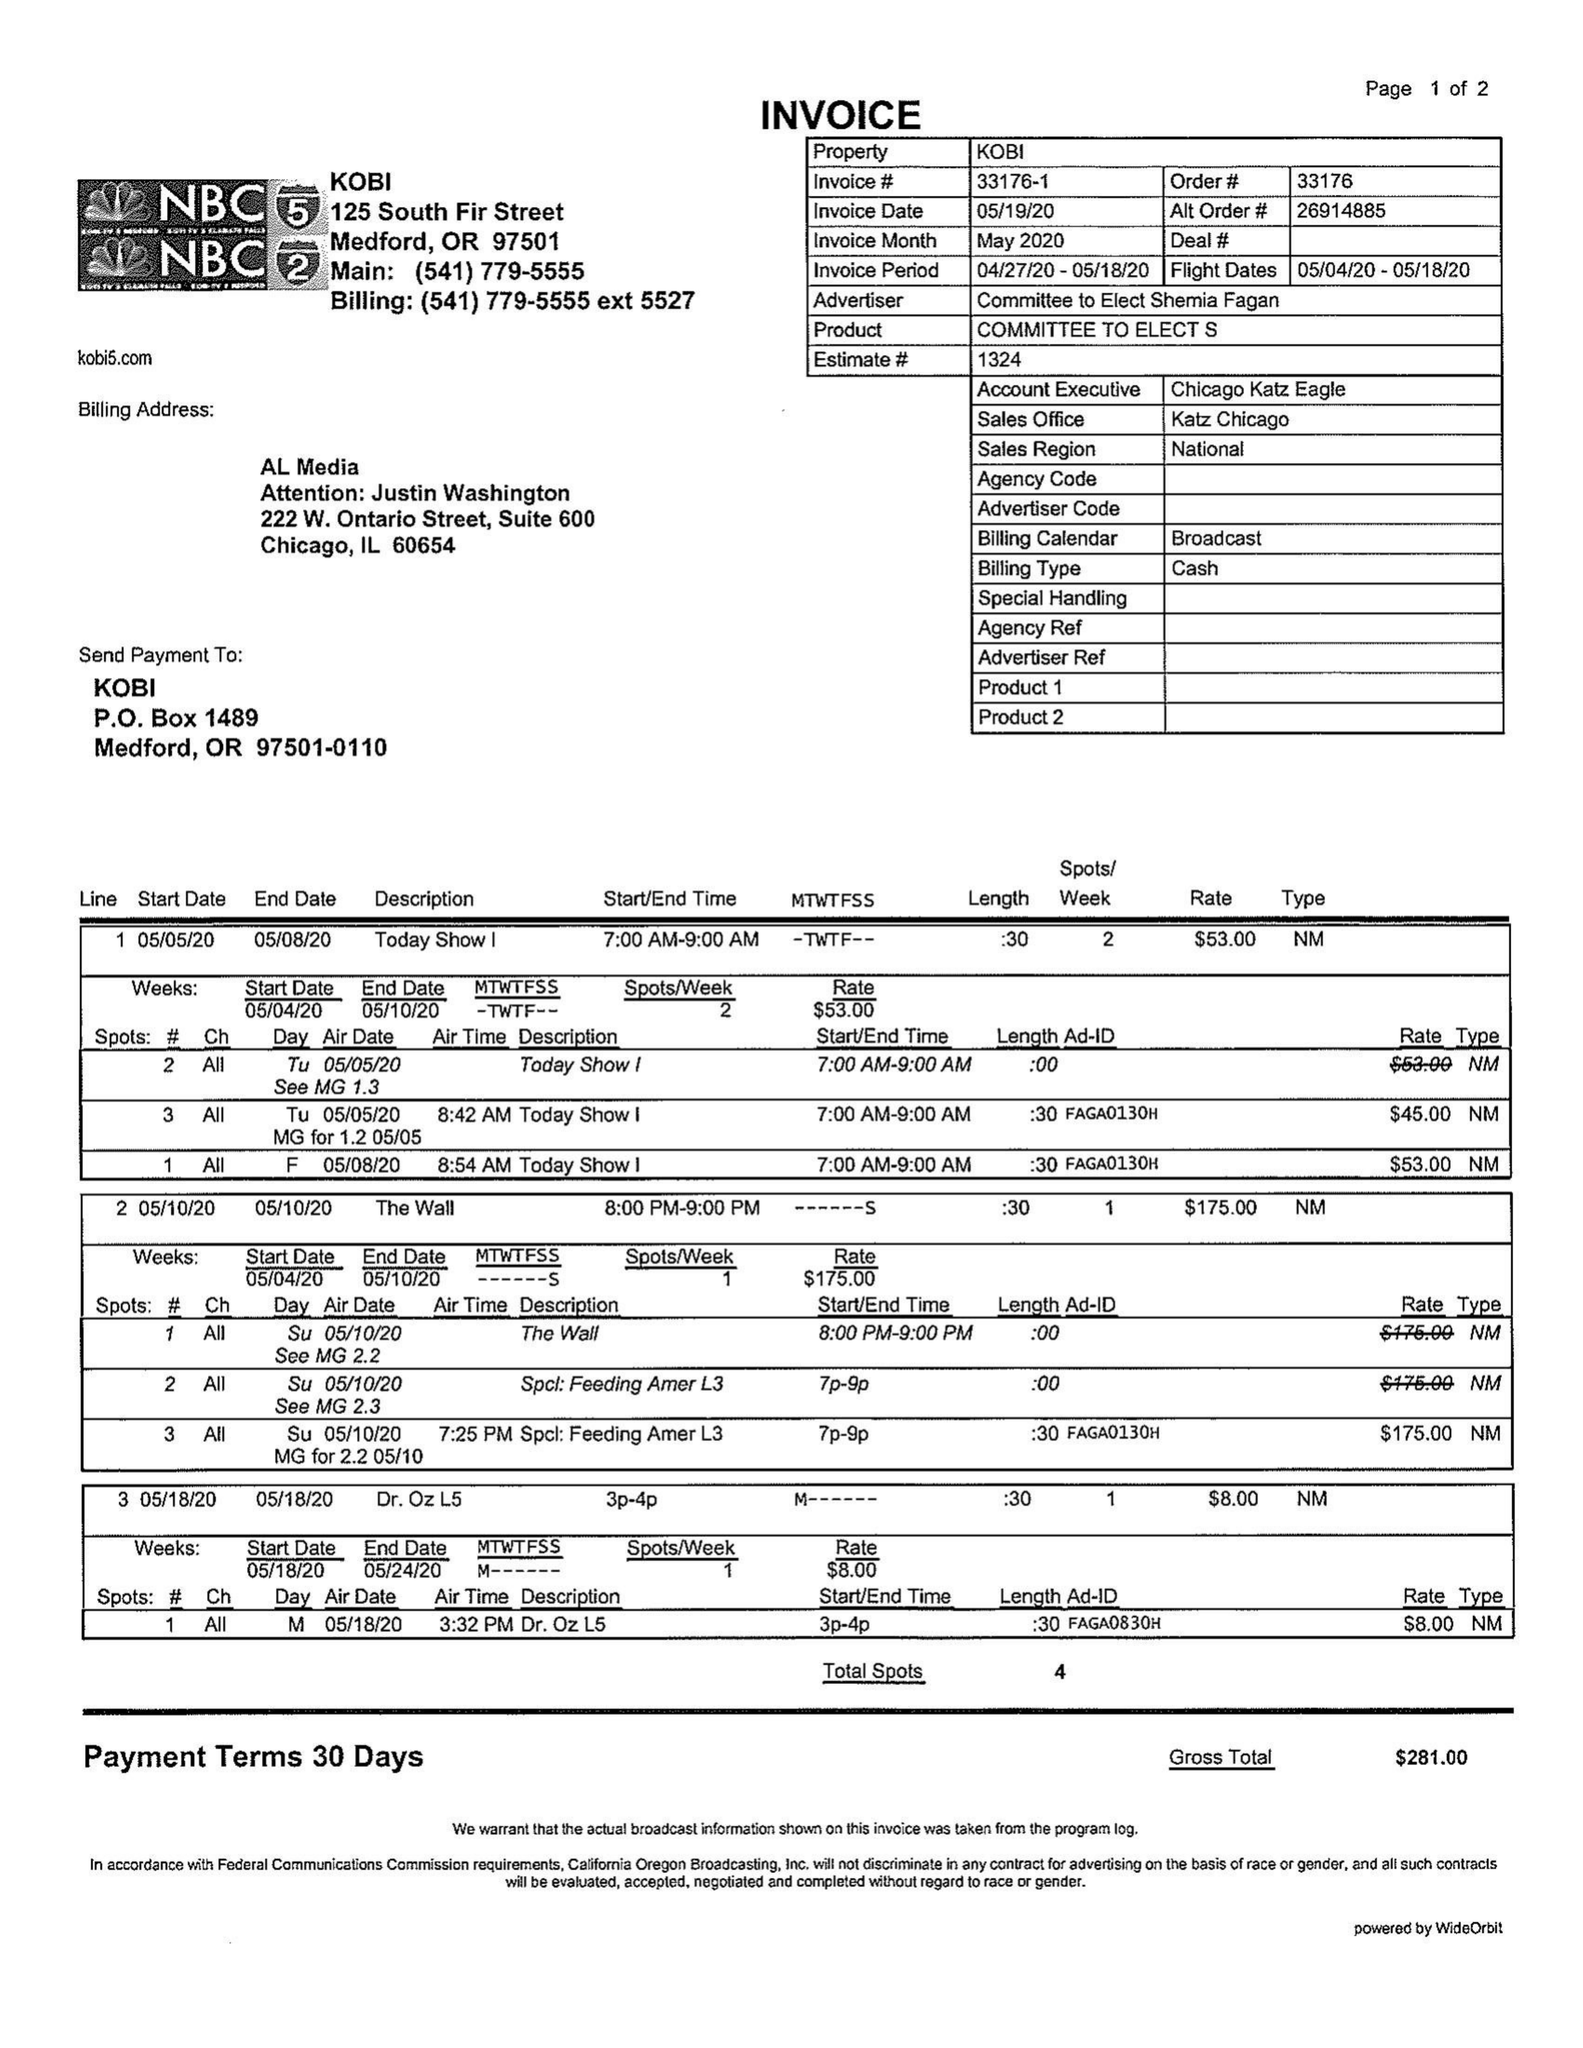What is the value for the contract_num?
Answer the question using a single word or phrase. 33176 